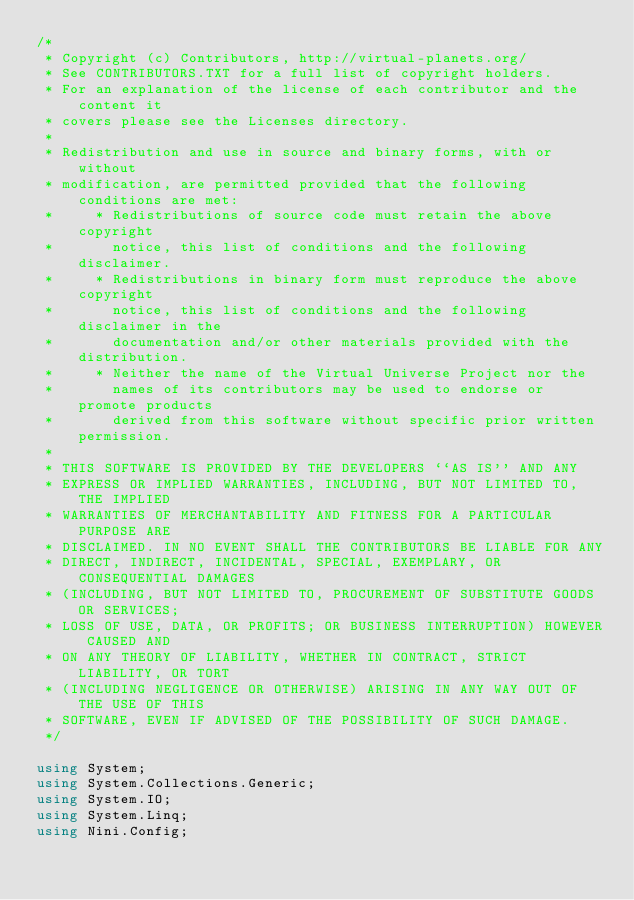<code> <loc_0><loc_0><loc_500><loc_500><_C#_>/*
 * Copyright (c) Contributors, http://virtual-planets.org/
 * See CONTRIBUTORS.TXT for a full list of copyright holders.
 * For an explanation of the license of each contributor and the content it 
 * covers please see the Licenses directory.
 *
 * Redistribution and use in source and binary forms, with or without
 * modification, are permitted provided that the following conditions are met:
 *     * Redistributions of source code must retain the above copyright
 *       notice, this list of conditions and the following disclaimer.
 *     * Redistributions in binary form must reproduce the above copyright
 *       notice, this list of conditions and the following disclaimer in the
 *       documentation and/or other materials provided with the distribution.
 *     * Neither the name of the Virtual Universe Project nor the
 *       names of its contributors may be used to endorse or promote products
 *       derived from this software without specific prior written permission.
 *
 * THIS SOFTWARE IS PROVIDED BY THE DEVELOPERS ``AS IS'' AND ANY
 * EXPRESS OR IMPLIED WARRANTIES, INCLUDING, BUT NOT LIMITED TO, THE IMPLIED
 * WARRANTIES OF MERCHANTABILITY AND FITNESS FOR A PARTICULAR PURPOSE ARE
 * DISCLAIMED. IN NO EVENT SHALL THE CONTRIBUTORS BE LIABLE FOR ANY
 * DIRECT, INDIRECT, INCIDENTAL, SPECIAL, EXEMPLARY, OR CONSEQUENTIAL DAMAGES
 * (INCLUDING, BUT NOT LIMITED TO, PROCUREMENT OF SUBSTITUTE GOODS OR SERVICES;
 * LOSS OF USE, DATA, OR PROFITS; OR BUSINESS INTERRUPTION) HOWEVER CAUSED AND
 * ON ANY THEORY OF LIABILITY, WHETHER IN CONTRACT, STRICT LIABILITY, OR TORT
 * (INCLUDING NEGLIGENCE OR OTHERWISE) ARISING IN ANY WAY OUT OF THE USE OF THIS
 * SOFTWARE, EVEN IF ADVISED OF THE POSSIBILITY OF SUCH DAMAGE.
 */

using System;
using System.Collections.Generic;
using System.IO;
using System.Linq;
using Nini.Config;</code> 